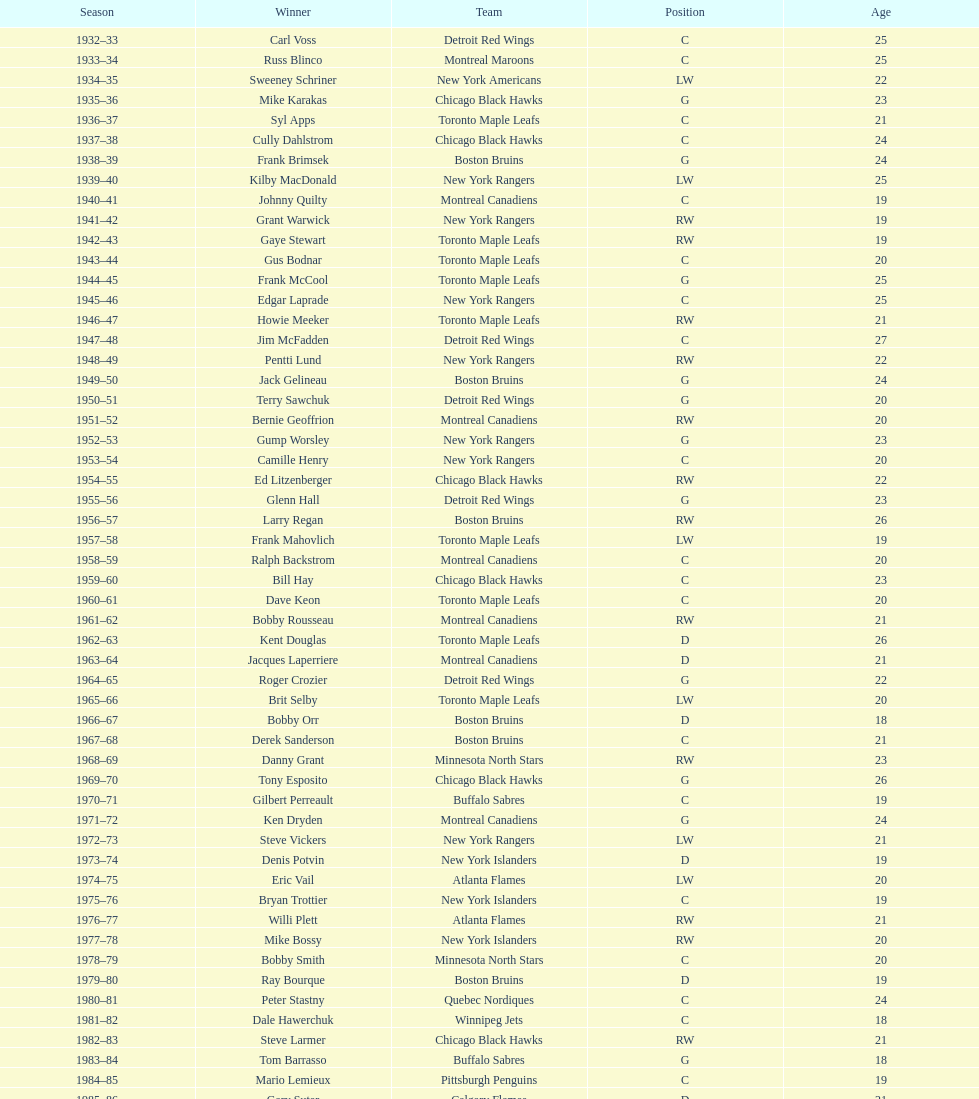Which team has the highest number of consecutive calder memorial trophy winners? Toronto Maple Leafs. 